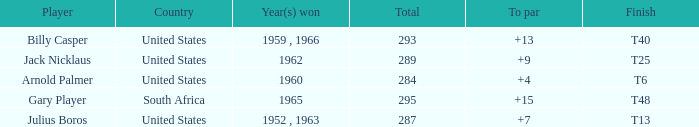What was Gary Player's highest total when his To par was over 15? None. Would you be able to parse every entry in this table? {'header': ['Player', 'Country', 'Year(s) won', 'Total', 'To par', 'Finish'], 'rows': [['Billy Casper', 'United States', '1959 , 1966', '293', '+13', 'T40'], ['Jack Nicklaus', 'United States', '1962', '289', '+9', 'T25'], ['Arnold Palmer', 'United States', '1960', '284', '+4', 'T6'], ['Gary Player', 'South Africa', '1965', '295', '+15', 'T48'], ['Julius Boros', 'United States', '1952 , 1963', '287', '+7', 'T13']]} 